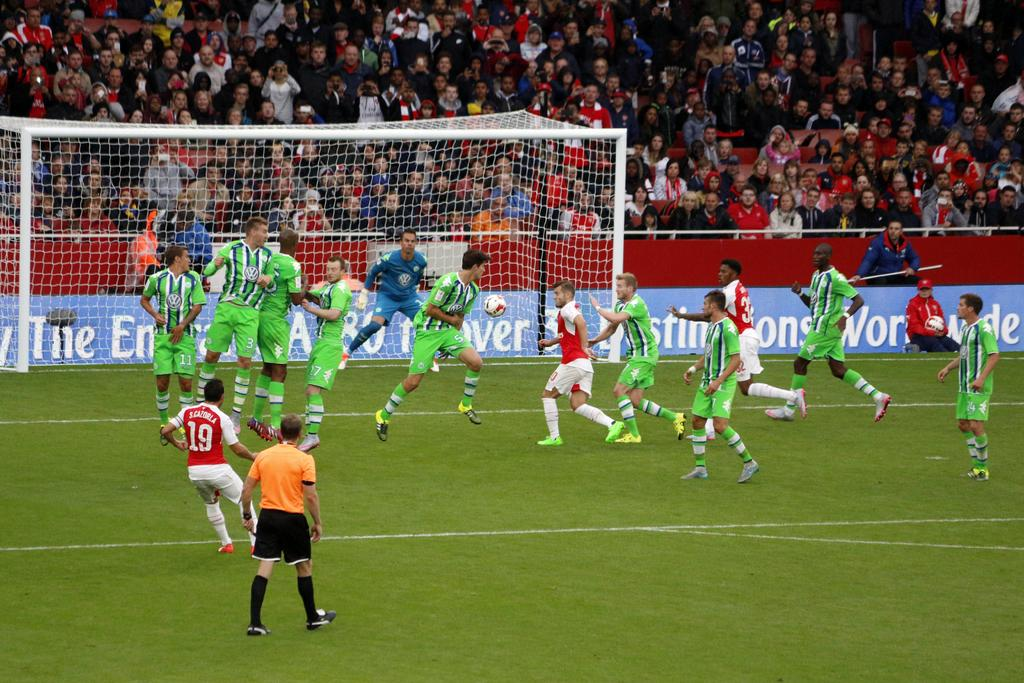What sport are the players engaged in within the image? The players are playing football in the image. Where is the football game taking place? The football game is taking place on a ground. Can you describe the audience in the image? In the background, there are audience members sitting on chairs, and some are standing. How many pests can be seen crawling on the football in the image? There are no pests visible in the image, as it features a football game with players and an audience. 